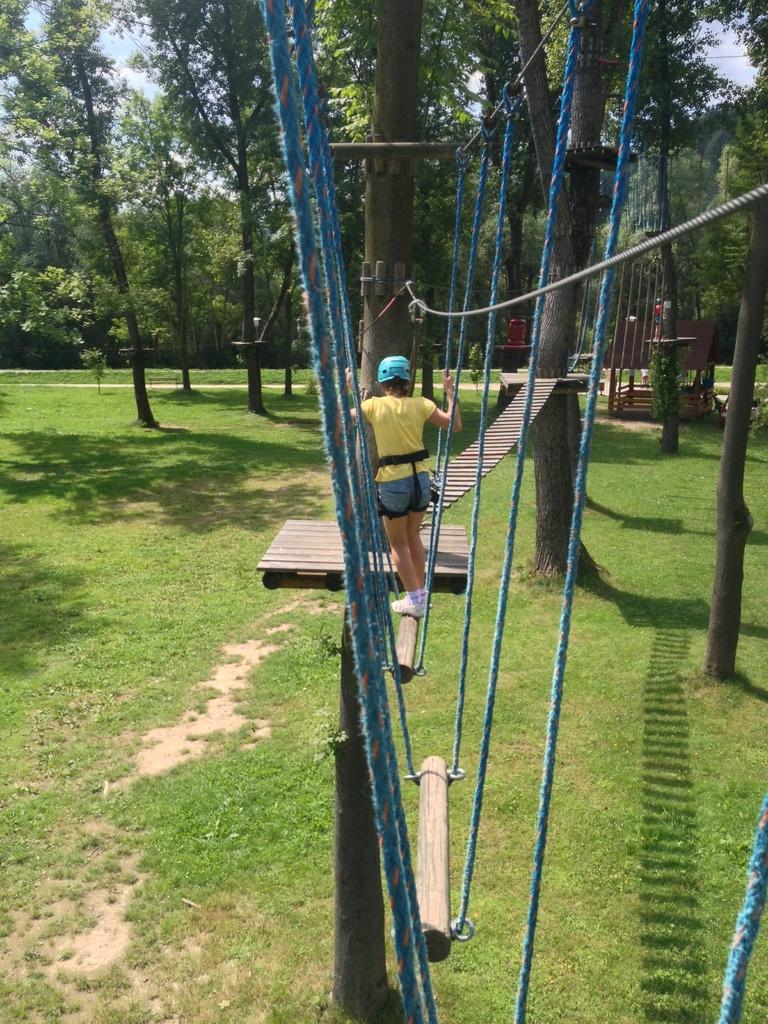Who or what is present in the image? There is a person in the image. What is the person wearing? The person is wearing a helmet. What is the person standing on? The person is standing on a wooden pole. What can be seen in the background of the image? There is a path, trees, grass, and the sky visible in the background of the image. How many jellyfish can be seen swimming in the sky in the image? There are no jellyfish present in the image, and the sky is visible, not the water where jellyfish would typically be found. 